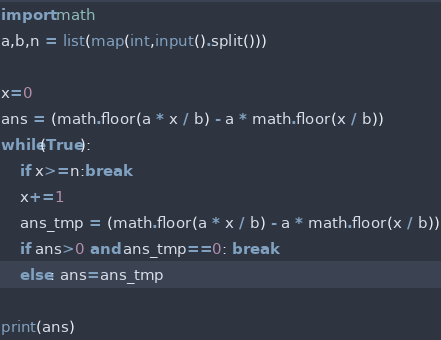<code> <loc_0><loc_0><loc_500><loc_500><_Python_>import math
a,b,n = list(map(int,input().split()))

x=0
ans = (math.floor(a * x / b) - a * math.floor(x / b))
while(True):
    if x>=n:break
    x+=1
    ans_tmp = (math.floor(a * x / b) - a * math.floor(x / b))
    if ans>0 and ans_tmp==0: break
    else: ans=ans_tmp

print(ans)</code> 